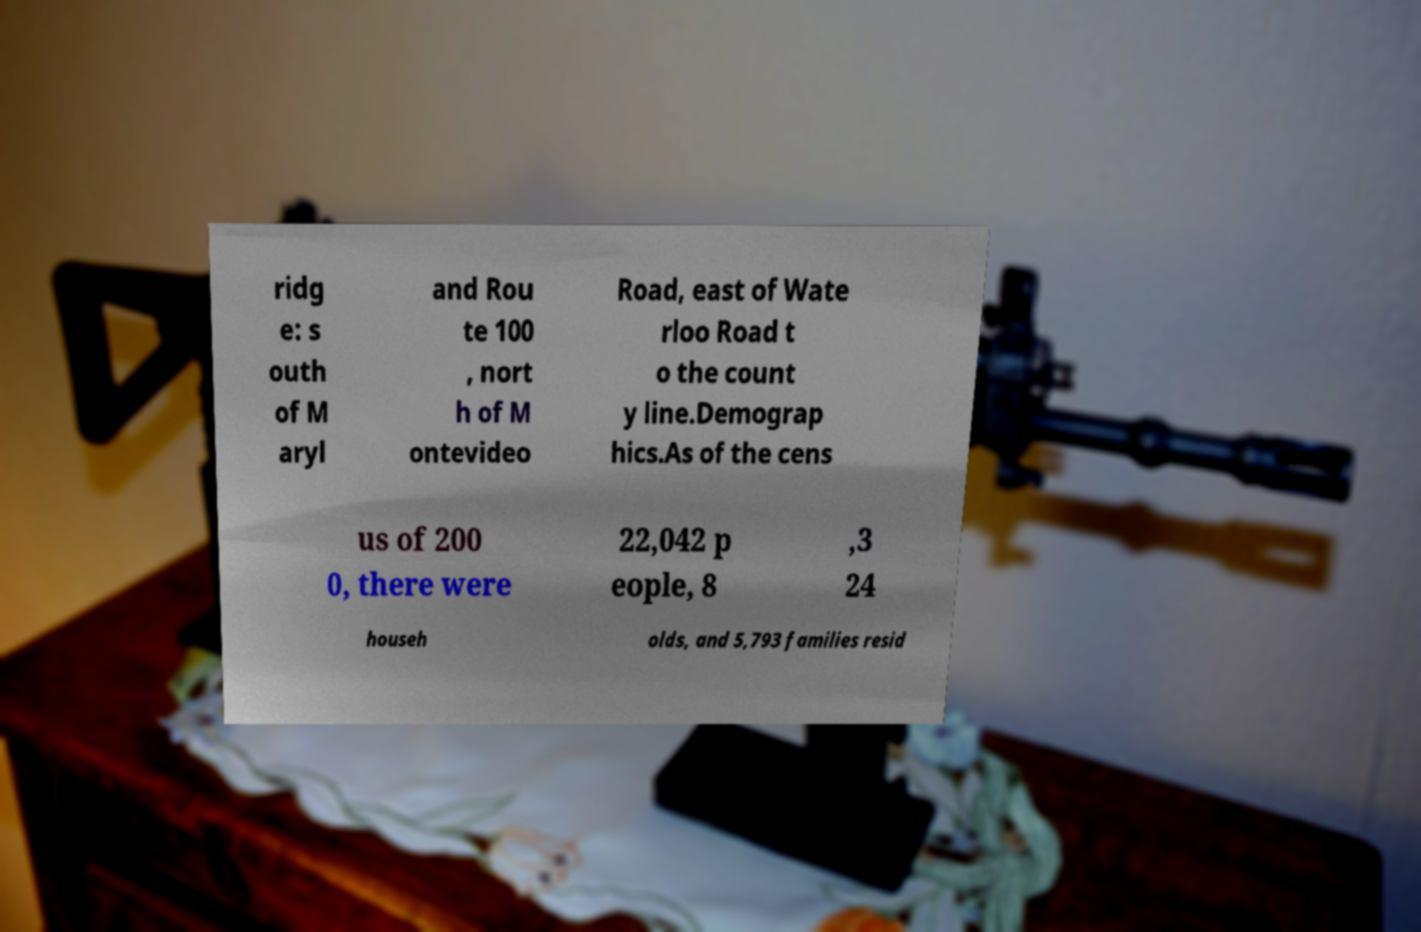I need the written content from this picture converted into text. Can you do that? ridg e: s outh of M aryl and Rou te 100 , nort h of M ontevideo Road, east of Wate rloo Road t o the count y line.Demograp hics.As of the cens us of 200 0, there were 22,042 p eople, 8 ,3 24 househ olds, and 5,793 families resid 